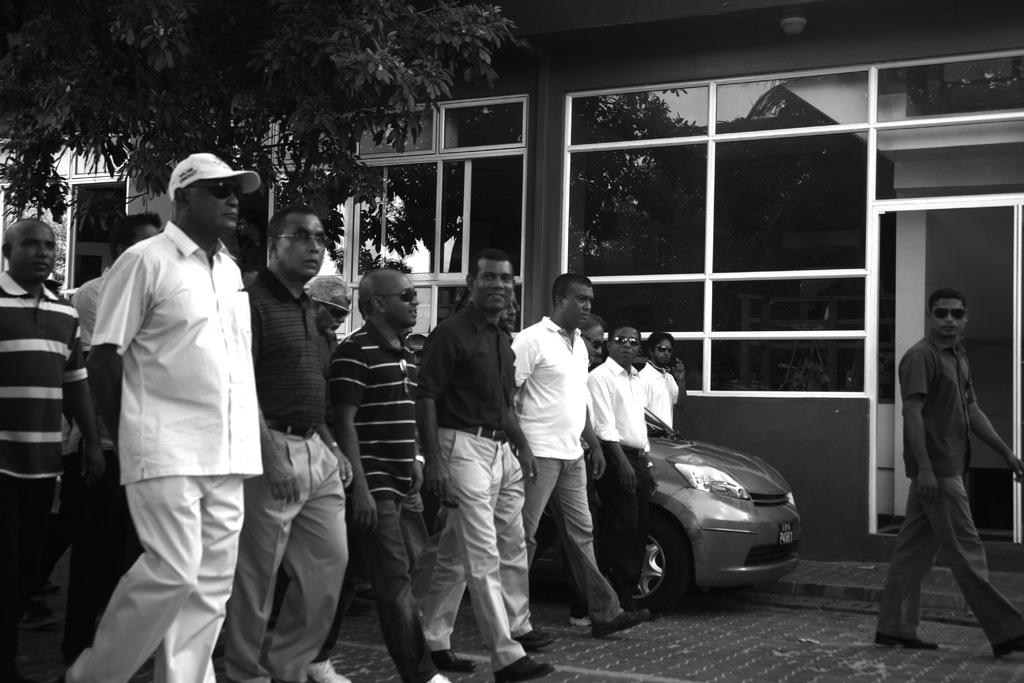What is the color scheme of the image? The image is black and white. Who or what can be seen in the image? There are people in the image. What type of buildings are present in the image? There are buildings with glass windows in the image. What other natural elements can be seen in the image? There are trees in the image. What mode of transportation is visible in the image? There is a vehicle in the image. What type of toys can be seen in the image? There are no toys present in the image. Is there a prison visible in the image? There is no prison present in the image. 